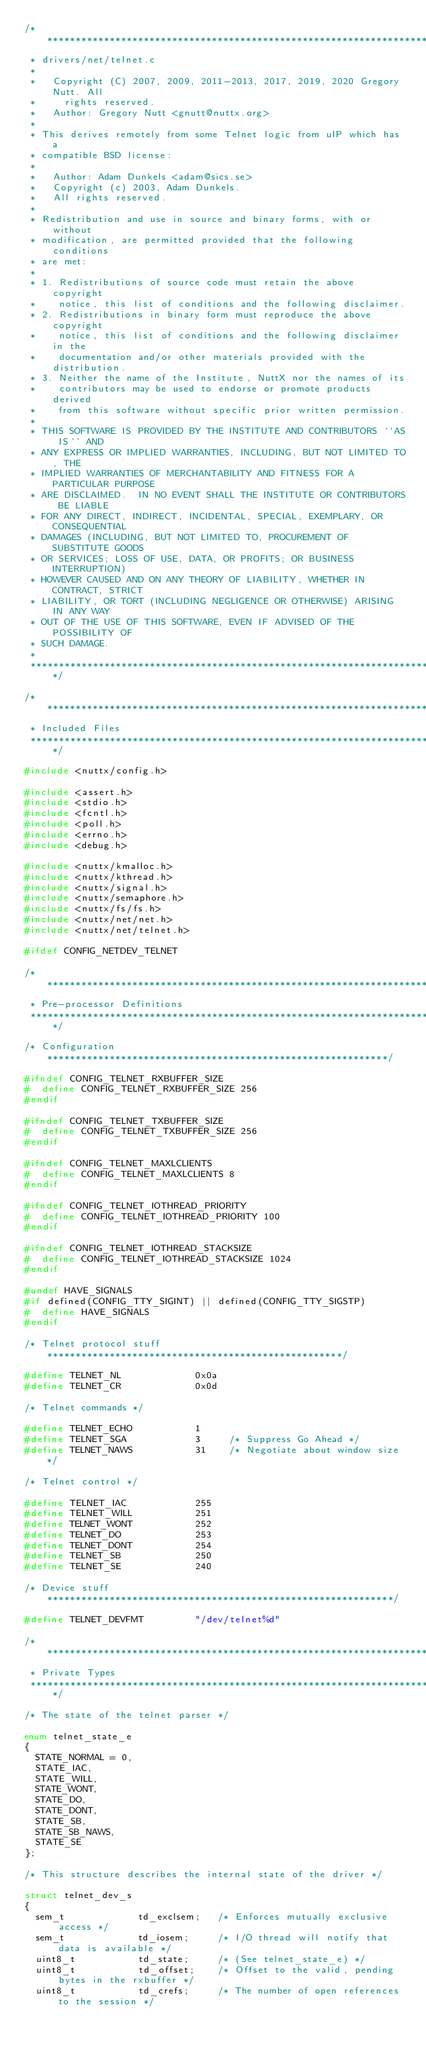<code> <loc_0><loc_0><loc_500><loc_500><_C_>/****************************************************************************
 * drivers/net/telnet.c
 *
 *   Copyright (C) 2007, 2009, 2011-2013, 2017, 2019, 2020 Gregory Nutt. All
 *     rights reserved.
 *   Author: Gregory Nutt <gnutt@nuttx.org>
 *
 * This derives remotely from some Telnet logic from uIP which has a
 * compatible BSD license:
 *
 *   Author: Adam Dunkels <adam@sics.se>
 *   Copyright (c) 2003, Adam Dunkels.
 *   All rights reserved.
 *
 * Redistribution and use in source and binary forms, with or without
 * modification, are permitted provided that the following conditions
 * are met:
 *
 * 1. Redistributions of source code must retain the above copyright
 *    notice, this list of conditions and the following disclaimer.
 * 2. Redistributions in binary form must reproduce the above copyright
 *    notice, this list of conditions and the following disclaimer in the
 *    documentation and/or other materials provided with the distribution.
 * 3. Neither the name of the Institute, NuttX nor the names of its
 *    contributors may be used to endorse or promote products derived
 *    from this software without specific prior written permission.
 *
 * THIS SOFTWARE IS PROVIDED BY THE INSTITUTE AND CONTRIBUTORS ``AS IS'' AND
 * ANY EXPRESS OR IMPLIED WARRANTIES, INCLUDING, BUT NOT LIMITED TO, THE
 * IMPLIED WARRANTIES OF MERCHANTABILITY AND FITNESS FOR A PARTICULAR PURPOSE
 * ARE DISCLAIMED.  IN NO EVENT SHALL THE INSTITUTE OR CONTRIBUTORS BE LIABLE
 * FOR ANY DIRECT, INDIRECT, INCIDENTAL, SPECIAL, EXEMPLARY, OR CONSEQUENTIAL
 * DAMAGES (INCLUDING, BUT NOT LIMITED TO, PROCUREMENT OF SUBSTITUTE GOODS
 * OR SERVICES; LOSS OF USE, DATA, OR PROFITS; OR BUSINESS INTERRUPTION)
 * HOWEVER CAUSED AND ON ANY THEORY OF LIABILITY, WHETHER IN CONTRACT, STRICT
 * LIABILITY, OR TORT (INCLUDING NEGLIGENCE OR OTHERWISE) ARISING IN ANY WAY
 * OUT OF THE USE OF THIS SOFTWARE, EVEN IF ADVISED OF THE POSSIBILITY OF
 * SUCH DAMAGE.
 *
 ****************************************************************************/

/****************************************************************************
 * Included Files
 ****************************************************************************/

#include <nuttx/config.h>

#include <assert.h>
#include <stdio.h>
#include <fcntl.h>
#include <poll.h>
#include <errno.h>
#include <debug.h>

#include <nuttx/kmalloc.h>
#include <nuttx/kthread.h>
#include <nuttx/signal.h>
#include <nuttx/semaphore.h>
#include <nuttx/fs/fs.h>
#include <nuttx/net/net.h>
#include <nuttx/net/telnet.h>

#ifdef CONFIG_NETDEV_TELNET

/****************************************************************************
 * Pre-processor Definitions
 ****************************************************************************/

/* Configuration ************************************************************/

#ifndef CONFIG_TELNET_RXBUFFER_SIZE
#  define CONFIG_TELNET_RXBUFFER_SIZE 256
#endif

#ifndef CONFIG_TELNET_TXBUFFER_SIZE
#  define CONFIG_TELNET_TXBUFFER_SIZE 256
#endif

#ifndef CONFIG_TELNET_MAXLCLIENTS
#  define CONFIG_TELNET_MAXLCLIENTS 8
#endif

#ifndef CONFIG_TELNET_IOTHREAD_PRIORITY
#  define CONFIG_TELNET_IOTHREAD_PRIORITY 100
#endif

#ifndef CONFIG_TELNET_IOTHREAD_STACKSIZE
#  define CONFIG_TELNET_IOTHREAD_STACKSIZE 1024
#endif

#undef HAVE_SIGNALS
#if defined(CONFIG_TTY_SIGINT) || defined(CONFIG_TTY_SIGSTP)
#  define HAVE_SIGNALS
#endif

/* Telnet protocol stuff ****************************************************/

#define TELNET_NL             0x0a
#define TELNET_CR             0x0d

/* Telnet commands */

#define TELNET_ECHO           1
#define TELNET_SGA            3     /* Suppress Go Ahead */
#define TELNET_NAWS           31    /* Negotiate about window size */

/* Telnet control */

#define TELNET_IAC            255
#define TELNET_WILL           251
#define TELNET_WONT           252
#define TELNET_DO             253
#define TELNET_DONT           254
#define TELNET_SB             250
#define TELNET_SE             240

/* Device stuff *************************************************************/

#define TELNET_DEVFMT         "/dev/telnet%d"

/****************************************************************************
 * Private Types
 ****************************************************************************/

/* The state of the telnet parser */

enum telnet_state_e
{
  STATE_NORMAL = 0,
  STATE_IAC,
  STATE_WILL,
  STATE_WONT,
  STATE_DO,
  STATE_DONT,
  STATE_SB,
  STATE_SB_NAWS,
  STATE_SE
};

/* This structure describes the internal state of the driver */

struct telnet_dev_s
{
  sem_t             td_exclsem;   /* Enforces mutually exclusive access */
  sem_t             td_iosem;     /* I/O thread will notify that data is available */
  uint8_t           td_state;     /* (See telnet_state_e) */
  uint8_t           td_offset;    /* Offset to the valid, pending bytes in the rxbuffer */
  uint8_t           td_crefs;     /* The number of open references to the session */</code> 